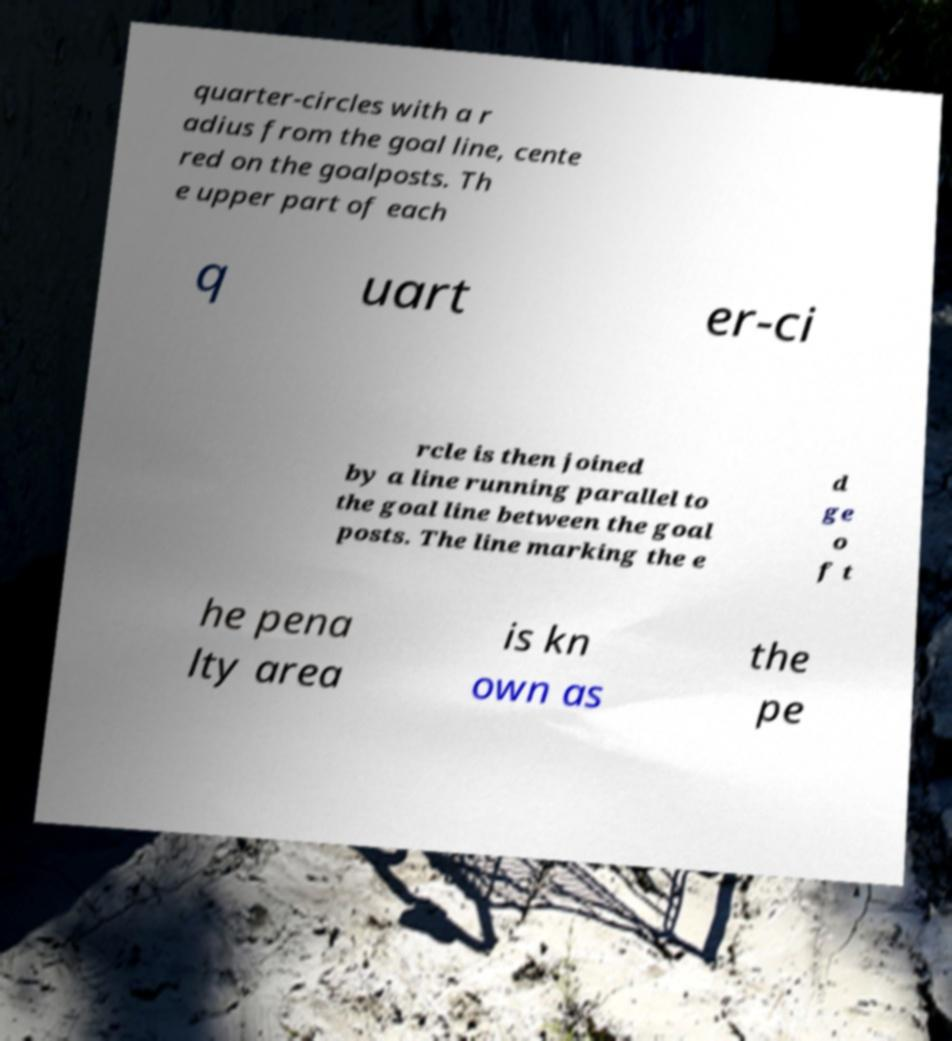Please read and relay the text visible in this image. What does it say? quarter-circles with a r adius from the goal line, cente red on the goalposts. Th e upper part of each q uart er-ci rcle is then joined by a line running parallel to the goal line between the goal posts. The line marking the e d ge o f t he pena lty area is kn own as the pe 